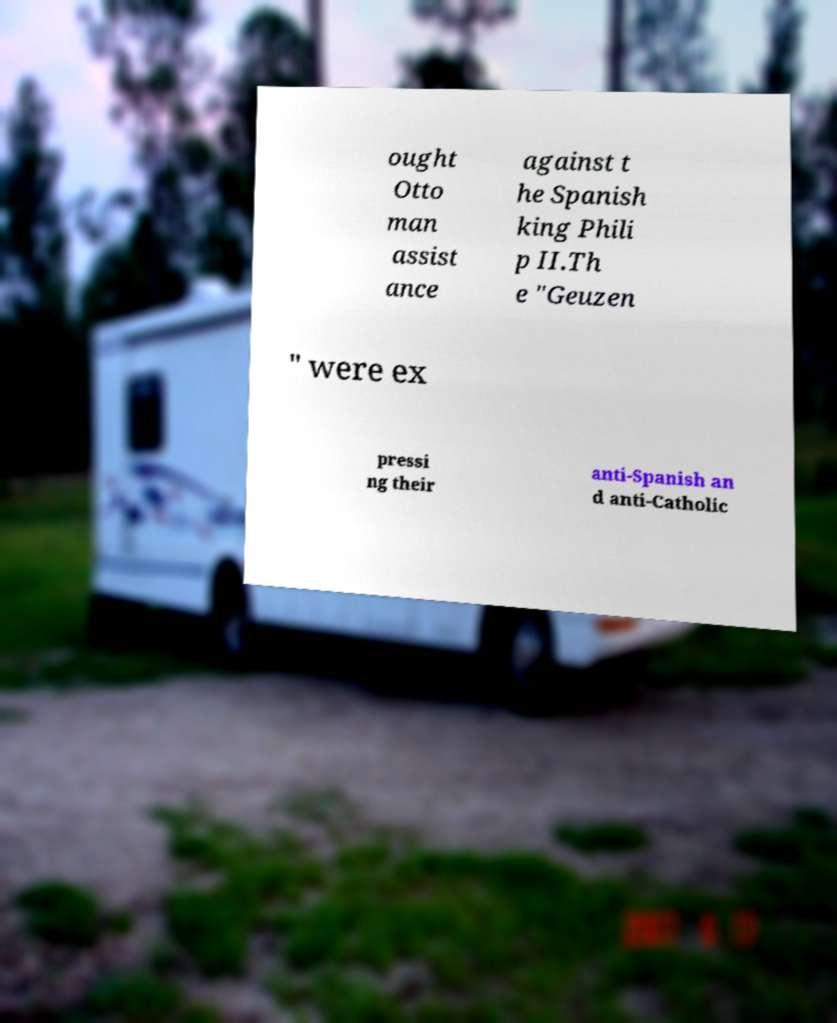Could you extract and type out the text from this image? ought Otto man assist ance against t he Spanish king Phili p II.Th e "Geuzen " were ex pressi ng their anti-Spanish an d anti-Catholic 